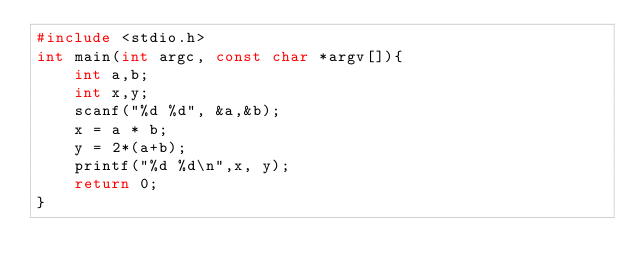<code> <loc_0><loc_0><loc_500><loc_500><_C_>#include <stdio.h>
int main(int argc, const char *argv[]){
    int a,b;
    int x,y;
    scanf("%d %d", &a,&b);
    x = a * b;
    y = 2*(a+b);
    printf("%d %d\n",x, y);
    return 0;
}</code> 